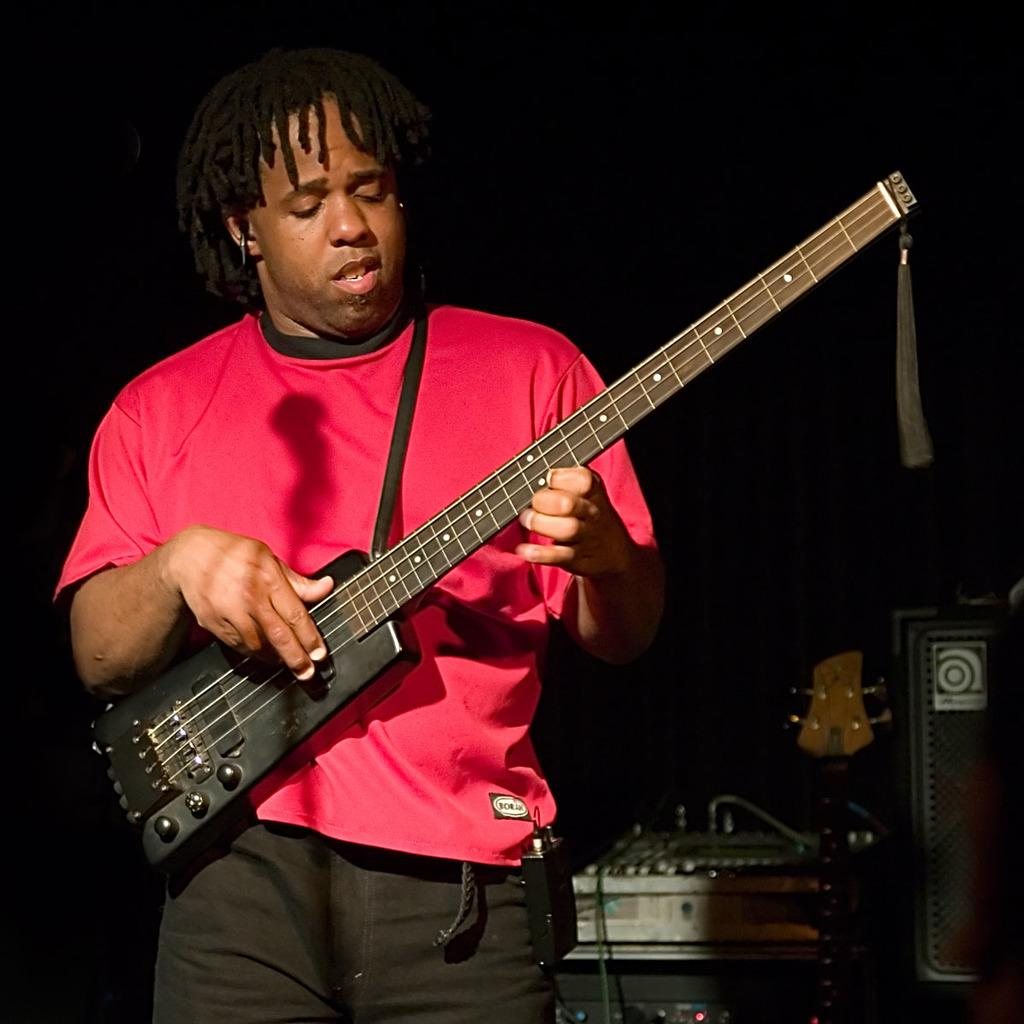What is the person in the image doing? The person is playing a musical instrument in the image. What can be seen on the right side of the image? There are objects on the right side of the image. How would you describe the lighting in the image? The background of the image is dark. What grade did the person receive for their performance in the image? There is no indication of a performance or grade in the image. 